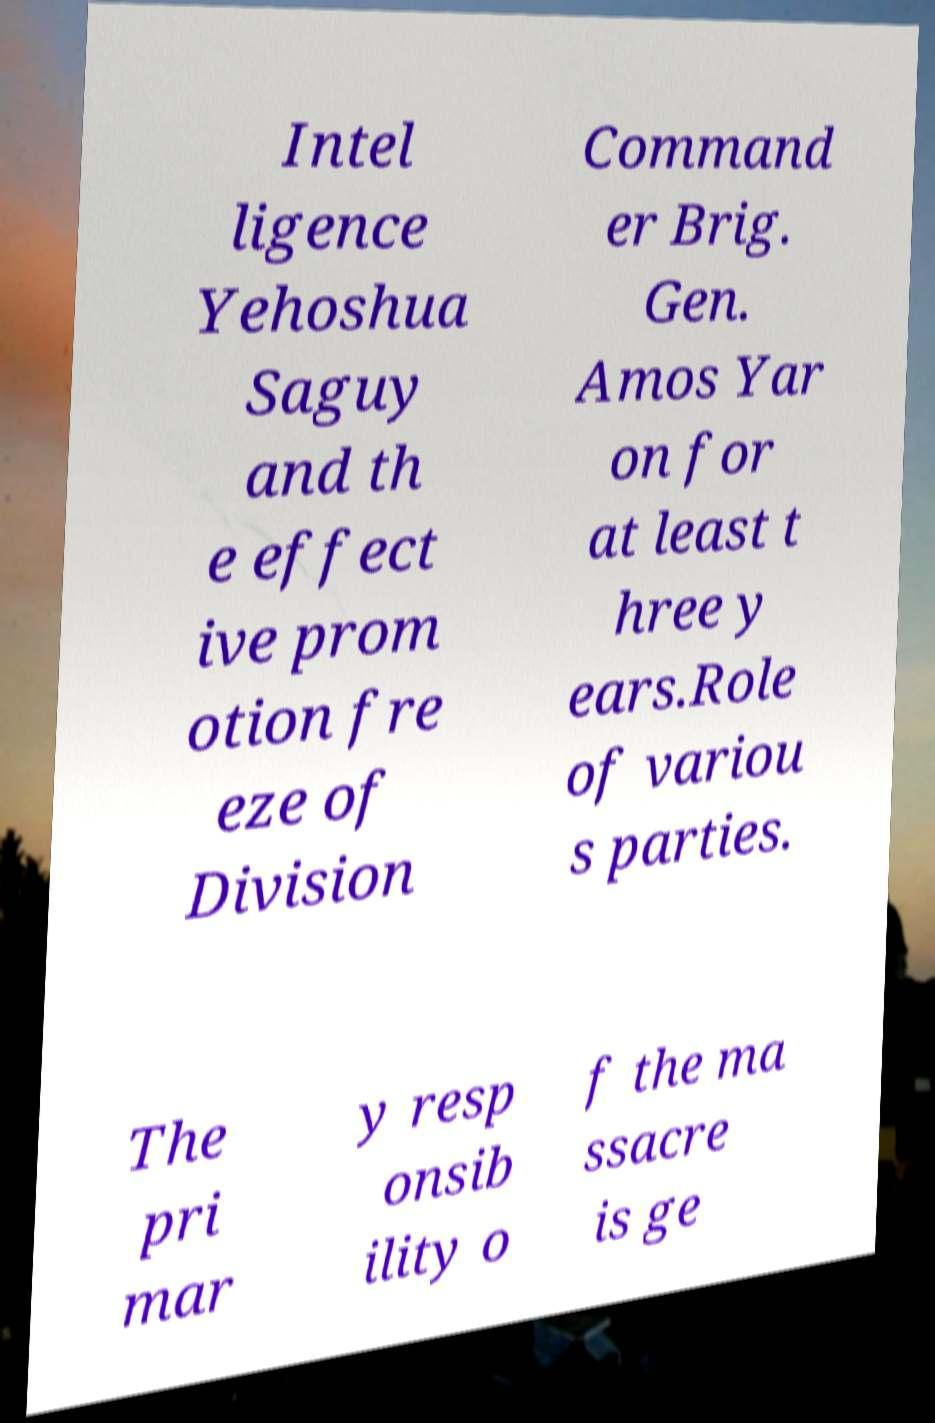For documentation purposes, I need the text within this image transcribed. Could you provide that? Intel ligence Yehoshua Saguy and th e effect ive prom otion fre eze of Division Command er Brig. Gen. Amos Yar on for at least t hree y ears.Role of variou s parties. The pri mar y resp onsib ility o f the ma ssacre is ge 